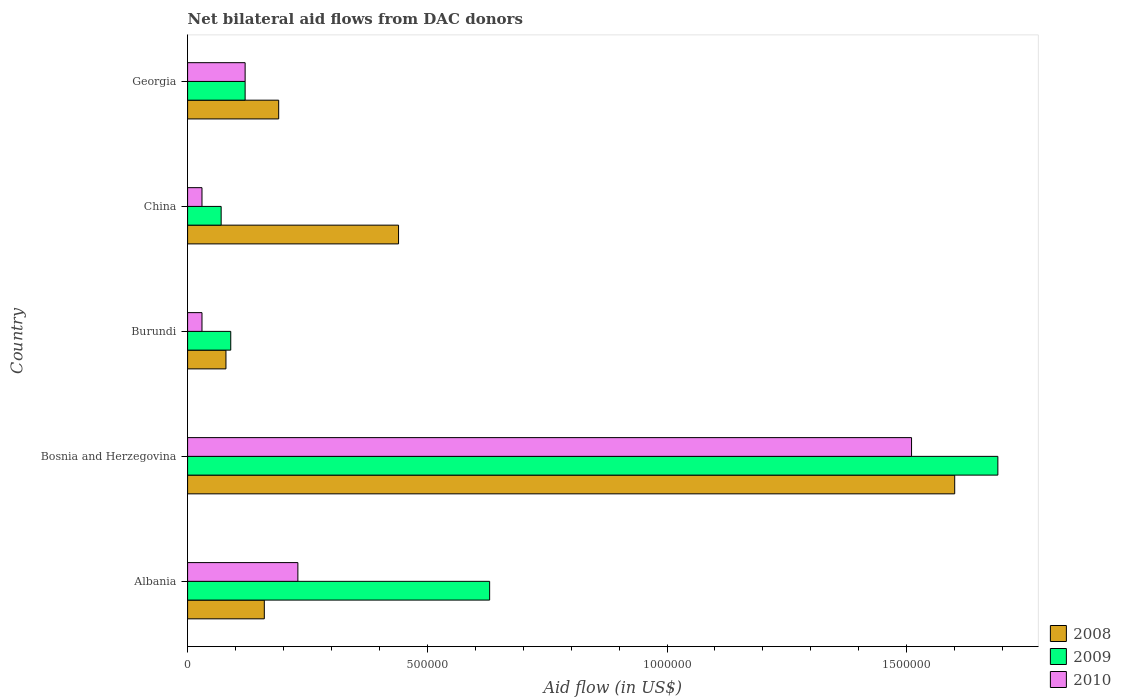How many groups of bars are there?
Make the answer very short. 5. How many bars are there on the 5th tick from the top?
Ensure brevity in your answer.  3. What is the label of the 2nd group of bars from the top?
Your answer should be very brief. China. What is the net bilateral aid flow in 2008 in Burundi?
Keep it short and to the point. 8.00e+04. Across all countries, what is the maximum net bilateral aid flow in 2008?
Ensure brevity in your answer.  1.60e+06. Across all countries, what is the minimum net bilateral aid flow in 2008?
Ensure brevity in your answer.  8.00e+04. In which country was the net bilateral aid flow in 2009 maximum?
Your answer should be compact. Bosnia and Herzegovina. In which country was the net bilateral aid flow in 2010 minimum?
Provide a short and direct response. Burundi. What is the total net bilateral aid flow in 2010 in the graph?
Your answer should be compact. 1.92e+06. What is the difference between the net bilateral aid flow in 2009 in Albania and that in China?
Your answer should be very brief. 5.60e+05. What is the average net bilateral aid flow in 2008 per country?
Provide a short and direct response. 4.94e+05. What is the difference between the net bilateral aid flow in 2009 and net bilateral aid flow in 2008 in China?
Your answer should be very brief. -3.70e+05. What is the ratio of the net bilateral aid flow in 2008 in Bosnia and Herzegovina to that in Georgia?
Provide a short and direct response. 8.42. What is the difference between the highest and the second highest net bilateral aid flow in 2008?
Make the answer very short. 1.16e+06. What is the difference between the highest and the lowest net bilateral aid flow in 2010?
Make the answer very short. 1.48e+06. In how many countries, is the net bilateral aid flow in 2008 greater than the average net bilateral aid flow in 2008 taken over all countries?
Your answer should be very brief. 1. Are all the bars in the graph horizontal?
Offer a very short reply. Yes. Are the values on the major ticks of X-axis written in scientific E-notation?
Provide a succinct answer. No. What is the title of the graph?
Your answer should be very brief. Net bilateral aid flows from DAC donors. What is the label or title of the X-axis?
Ensure brevity in your answer.  Aid flow (in US$). What is the label or title of the Y-axis?
Offer a terse response. Country. What is the Aid flow (in US$) of 2008 in Albania?
Ensure brevity in your answer.  1.60e+05. What is the Aid flow (in US$) in 2009 in Albania?
Offer a very short reply. 6.30e+05. What is the Aid flow (in US$) in 2010 in Albania?
Give a very brief answer. 2.30e+05. What is the Aid flow (in US$) of 2008 in Bosnia and Herzegovina?
Your answer should be very brief. 1.60e+06. What is the Aid flow (in US$) in 2009 in Bosnia and Herzegovina?
Ensure brevity in your answer.  1.69e+06. What is the Aid flow (in US$) in 2010 in Bosnia and Herzegovina?
Provide a succinct answer. 1.51e+06. What is the Aid flow (in US$) of 2009 in Burundi?
Your answer should be very brief. 9.00e+04. What is the Aid flow (in US$) in 2009 in China?
Offer a terse response. 7.00e+04. Across all countries, what is the maximum Aid flow (in US$) of 2008?
Offer a very short reply. 1.60e+06. Across all countries, what is the maximum Aid flow (in US$) of 2009?
Offer a terse response. 1.69e+06. Across all countries, what is the maximum Aid flow (in US$) of 2010?
Provide a short and direct response. 1.51e+06. Across all countries, what is the minimum Aid flow (in US$) in 2008?
Provide a succinct answer. 8.00e+04. Across all countries, what is the minimum Aid flow (in US$) in 2009?
Keep it short and to the point. 7.00e+04. What is the total Aid flow (in US$) of 2008 in the graph?
Give a very brief answer. 2.47e+06. What is the total Aid flow (in US$) in 2009 in the graph?
Your answer should be very brief. 2.60e+06. What is the total Aid flow (in US$) in 2010 in the graph?
Give a very brief answer. 1.92e+06. What is the difference between the Aid flow (in US$) of 2008 in Albania and that in Bosnia and Herzegovina?
Provide a short and direct response. -1.44e+06. What is the difference between the Aid flow (in US$) of 2009 in Albania and that in Bosnia and Herzegovina?
Give a very brief answer. -1.06e+06. What is the difference between the Aid flow (in US$) in 2010 in Albania and that in Bosnia and Herzegovina?
Make the answer very short. -1.28e+06. What is the difference between the Aid flow (in US$) of 2009 in Albania and that in Burundi?
Provide a succinct answer. 5.40e+05. What is the difference between the Aid flow (in US$) of 2010 in Albania and that in Burundi?
Ensure brevity in your answer.  2.00e+05. What is the difference between the Aid flow (in US$) in 2008 in Albania and that in China?
Provide a short and direct response. -2.80e+05. What is the difference between the Aid flow (in US$) of 2009 in Albania and that in China?
Your answer should be very brief. 5.60e+05. What is the difference between the Aid flow (in US$) in 2009 in Albania and that in Georgia?
Your answer should be compact. 5.10e+05. What is the difference between the Aid flow (in US$) in 2010 in Albania and that in Georgia?
Your answer should be very brief. 1.10e+05. What is the difference between the Aid flow (in US$) in 2008 in Bosnia and Herzegovina and that in Burundi?
Your response must be concise. 1.52e+06. What is the difference between the Aid flow (in US$) of 2009 in Bosnia and Herzegovina and that in Burundi?
Keep it short and to the point. 1.60e+06. What is the difference between the Aid flow (in US$) in 2010 in Bosnia and Herzegovina and that in Burundi?
Your answer should be compact. 1.48e+06. What is the difference between the Aid flow (in US$) in 2008 in Bosnia and Herzegovina and that in China?
Your response must be concise. 1.16e+06. What is the difference between the Aid flow (in US$) of 2009 in Bosnia and Herzegovina and that in China?
Your answer should be very brief. 1.62e+06. What is the difference between the Aid flow (in US$) of 2010 in Bosnia and Herzegovina and that in China?
Offer a terse response. 1.48e+06. What is the difference between the Aid flow (in US$) in 2008 in Bosnia and Herzegovina and that in Georgia?
Your answer should be compact. 1.41e+06. What is the difference between the Aid flow (in US$) in 2009 in Bosnia and Herzegovina and that in Georgia?
Your answer should be very brief. 1.57e+06. What is the difference between the Aid flow (in US$) in 2010 in Bosnia and Herzegovina and that in Georgia?
Give a very brief answer. 1.39e+06. What is the difference between the Aid flow (in US$) in 2008 in Burundi and that in China?
Your response must be concise. -3.60e+05. What is the difference between the Aid flow (in US$) in 2008 in Burundi and that in Georgia?
Offer a terse response. -1.10e+05. What is the difference between the Aid flow (in US$) in 2009 in Burundi and that in Georgia?
Provide a succinct answer. -3.00e+04. What is the difference between the Aid flow (in US$) in 2009 in China and that in Georgia?
Provide a succinct answer. -5.00e+04. What is the difference between the Aid flow (in US$) in 2010 in China and that in Georgia?
Make the answer very short. -9.00e+04. What is the difference between the Aid flow (in US$) of 2008 in Albania and the Aid flow (in US$) of 2009 in Bosnia and Herzegovina?
Offer a very short reply. -1.53e+06. What is the difference between the Aid flow (in US$) of 2008 in Albania and the Aid flow (in US$) of 2010 in Bosnia and Herzegovina?
Provide a short and direct response. -1.35e+06. What is the difference between the Aid flow (in US$) in 2009 in Albania and the Aid flow (in US$) in 2010 in Bosnia and Herzegovina?
Your answer should be compact. -8.80e+05. What is the difference between the Aid flow (in US$) of 2009 in Albania and the Aid flow (in US$) of 2010 in Burundi?
Give a very brief answer. 6.00e+05. What is the difference between the Aid flow (in US$) of 2008 in Albania and the Aid flow (in US$) of 2009 in China?
Your answer should be compact. 9.00e+04. What is the difference between the Aid flow (in US$) of 2008 in Albania and the Aid flow (in US$) of 2010 in China?
Your response must be concise. 1.30e+05. What is the difference between the Aid flow (in US$) in 2009 in Albania and the Aid flow (in US$) in 2010 in Georgia?
Offer a very short reply. 5.10e+05. What is the difference between the Aid flow (in US$) of 2008 in Bosnia and Herzegovina and the Aid flow (in US$) of 2009 in Burundi?
Your answer should be compact. 1.51e+06. What is the difference between the Aid flow (in US$) of 2008 in Bosnia and Herzegovina and the Aid flow (in US$) of 2010 in Burundi?
Your answer should be very brief. 1.57e+06. What is the difference between the Aid flow (in US$) of 2009 in Bosnia and Herzegovina and the Aid flow (in US$) of 2010 in Burundi?
Your response must be concise. 1.66e+06. What is the difference between the Aid flow (in US$) in 2008 in Bosnia and Herzegovina and the Aid flow (in US$) in 2009 in China?
Ensure brevity in your answer.  1.53e+06. What is the difference between the Aid flow (in US$) in 2008 in Bosnia and Herzegovina and the Aid flow (in US$) in 2010 in China?
Your answer should be compact. 1.57e+06. What is the difference between the Aid flow (in US$) in 2009 in Bosnia and Herzegovina and the Aid flow (in US$) in 2010 in China?
Provide a short and direct response. 1.66e+06. What is the difference between the Aid flow (in US$) in 2008 in Bosnia and Herzegovina and the Aid flow (in US$) in 2009 in Georgia?
Provide a short and direct response. 1.48e+06. What is the difference between the Aid flow (in US$) of 2008 in Bosnia and Herzegovina and the Aid flow (in US$) of 2010 in Georgia?
Provide a succinct answer. 1.48e+06. What is the difference between the Aid flow (in US$) of 2009 in Bosnia and Herzegovina and the Aid flow (in US$) of 2010 in Georgia?
Provide a short and direct response. 1.57e+06. What is the difference between the Aid flow (in US$) in 2008 in Burundi and the Aid flow (in US$) in 2009 in China?
Provide a succinct answer. 10000. What is the difference between the Aid flow (in US$) in 2008 in Burundi and the Aid flow (in US$) in 2010 in China?
Make the answer very short. 5.00e+04. What is the difference between the Aid flow (in US$) of 2009 in Burundi and the Aid flow (in US$) of 2010 in China?
Give a very brief answer. 6.00e+04. What is the difference between the Aid flow (in US$) of 2008 in Burundi and the Aid flow (in US$) of 2009 in Georgia?
Provide a short and direct response. -4.00e+04. What is the difference between the Aid flow (in US$) in 2009 in China and the Aid flow (in US$) in 2010 in Georgia?
Offer a terse response. -5.00e+04. What is the average Aid flow (in US$) in 2008 per country?
Ensure brevity in your answer.  4.94e+05. What is the average Aid flow (in US$) of 2009 per country?
Provide a short and direct response. 5.20e+05. What is the average Aid flow (in US$) of 2010 per country?
Provide a succinct answer. 3.84e+05. What is the difference between the Aid flow (in US$) of 2008 and Aid flow (in US$) of 2009 in Albania?
Offer a terse response. -4.70e+05. What is the difference between the Aid flow (in US$) of 2008 and Aid flow (in US$) of 2010 in Albania?
Offer a very short reply. -7.00e+04. What is the difference between the Aid flow (in US$) of 2009 and Aid flow (in US$) of 2010 in Albania?
Ensure brevity in your answer.  4.00e+05. What is the difference between the Aid flow (in US$) in 2008 and Aid flow (in US$) in 2009 in Bosnia and Herzegovina?
Give a very brief answer. -9.00e+04. What is the difference between the Aid flow (in US$) in 2008 and Aid flow (in US$) in 2010 in Bosnia and Herzegovina?
Provide a short and direct response. 9.00e+04. What is the difference between the Aid flow (in US$) of 2008 and Aid flow (in US$) of 2009 in Burundi?
Ensure brevity in your answer.  -10000. What is the difference between the Aid flow (in US$) in 2009 and Aid flow (in US$) in 2010 in Burundi?
Provide a short and direct response. 6.00e+04. What is the difference between the Aid flow (in US$) of 2008 and Aid flow (in US$) of 2009 in China?
Give a very brief answer. 3.70e+05. What is the difference between the Aid flow (in US$) of 2008 and Aid flow (in US$) of 2010 in China?
Your answer should be very brief. 4.10e+05. What is the difference between the Aid flow (in US$) in 2009 and Aid flow (in US$) in 2010 in China?
Your answer should be compact. 4.00e+04. What is the ratio of the Aid flow (in US$) in 2008 in Albania to that in Bosnia and Herzegovina?
Make the answer very short. 0.1. What is the ratio of the Aid flow (in US$) of 2009 in Albania to that in Bosnia and Herzegovina?
Your answer should be compact. 0.37. What is the ratio of the Aid flow (in US$) of 2010 in Albania to that in Bosnia and Herzegovina?
Give a very brief answer. 0.15. What is the ratio of the Aid flow (in US$) of 2009 in Albania to that in Burundi?
Offer a very short reply. 7. What is the ratio of the Aid flow (in US$) of 2010 in Albania to that in Burundi?
Ensure brevity in your answer.  7.67. What is the ratio of the Aid flow (in US$) in 2008 in Albania to that in China?
Your response must be concise. 0.36. What is the ratio of the Aid flow (in US$) of 2010 in Albania to that in China?
Provide a short and direct response. 7.67. What is the ratio of the Aid flow (in US$) of 2008 in Albania to that in Georgia?
Provide a succinct answer. 0.84. What is the ratio of the Aid flow (in US$) of 2009 in Albania to that in Georgia?
Your answer should be very brief. 5.25. What is the ratio of the Aid flow (in US$) in 2010 in Albania to that in Georgia?
Your response must be concise. 1.92. What is the ratio of the Aid flow (in US$) of 2009 in Bosnia and Herzegovina to that in Burundi?
Ensure brevity in your answer.  18.78. What is the ratio of the Aid flow (in US$) in 2010 in Bosnia and Herzegovina to that in Burundi?
Provide a succinct answer. 50.33. What is the ratio of the Aid flow (in US$) in 2008 in Bosnia and Herzegovina to that in China?
Your answer should be very brief. 3.64. What is the ratio of the Aid flow (in US$) in 2009 in Bosnia and Herzegovina to that in China?
Provide a short and direct response. 24.14. What is the ratio of the Aid flow (in US$) of 2010 in Bosnia and Herzegovina to that in China?
Make the answer very short. 50.33. What is the ratio of the Aid flow (in US$) in 2008 in Bosnia and Herzegovina to that in Georgia?
Offer a terse response. 8.42. What is the ratio of the Aid flow (in US$) in 2009 in Bosnia and Herzegovina to that in Georgia?
Your response must be concise. 14.08. What is the ratio of the Aid flow (in US$) of 2010 in Bosnia and Herzegovina to that in Georgia?
Make the answer very short. 12.58. What is the ratio of the Aid flow (in US$) in 2008 in Burundi to that in China?
Offer a very short reply. 0.18. What is the ratio of the Aid flow (in US$) in 2009 in Burundi to that in China?
Give a very brief answer. 1.29. What is the ratio of the Aid flow (in US$) of 2010 in Burundi to that in China?
Ensure brevity in your answer.  1. What is the ratio of the Aid flow (in US$) in 2008 in Burundi to that in Georgia?
Your answer should be very brief. 0.42. What is the ratio of the Aid flow (in US$) of 2008 in China to that in Georgia?
Make the answer very short. 2.32. What is the ratio of the Aid flow (in US$) of 2009 in China to that in Georgia?
Provide a succinct answer. 0.58. What is the difference between the highest and the second highest Aid flow (in US$) of 2008?
Your answer should be very brief. 1.16e+06. What is the difference between the highest and the second highest Aid flow (in US$) of 2009?
Keep it short and to the point. 1.06e+06. What is the difference between the highest and the second highest Aid flow (in US$) in 2010?
Your answer should be compact. 1.28e+06. What is the difference between the highest and the lowest Aid flow (in US$) in 2008?
Make the answer very short. 1.52e+06. What is the difference between the highest and the lowest Aid flow (in US$) in 2009?
Your answer should be compact. 1.62e+06. What is the difference between the highest and the lowest Aid flow (in US$) in 2010?
Keep it short and to the point. 1.48e+06. 